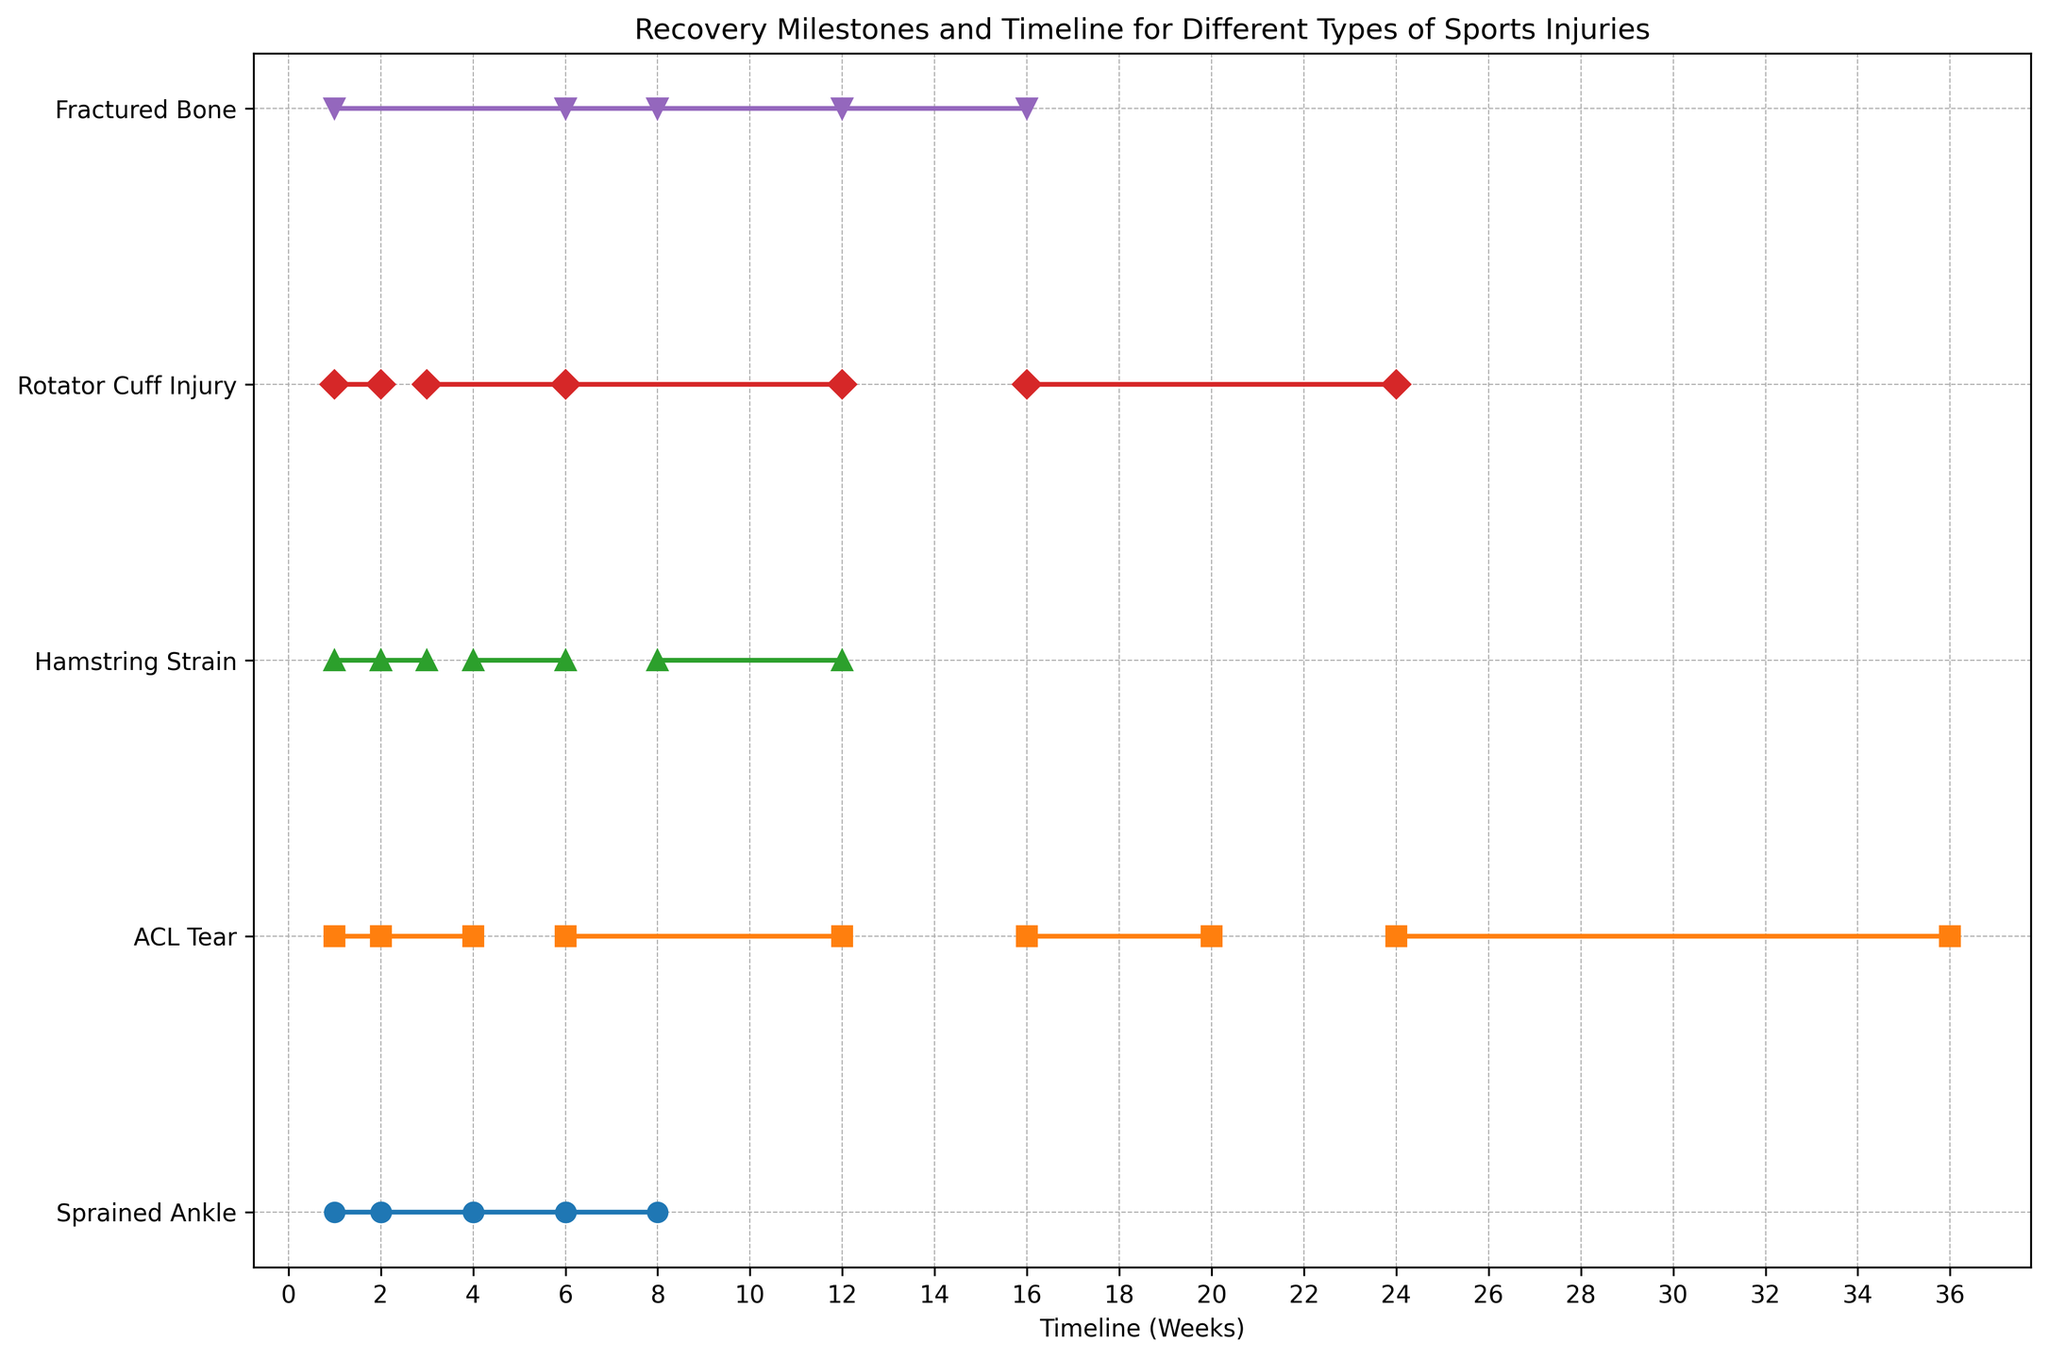What is the shortest initial rest period among all injury types? The shortest initial rest period can be determined by looking for the smallest number in the "Initial Rest" timeline range across all injury types. For Sprained Ankle, ACL Tear, Hamstring Strain, and Rotator Cuff Injury, the range is 1-2 weeks. For Fractured Bone, it is 1-6 weeks. The shortest is 1 week.
Answer: 1 week Which injury type has the longest recovery period before full return to activity? To find the longest recovery period before full return to activity, check the upper limit of the "Full Activity" or "Full Return to Sports" timeline for each injury type. Sprained Ankle is 6-8 weeks, ACL Tear is 24-36 weeks, Hamstring Strain is 8-12 weeks, Rotator Cuff Injury is 16-24 weeks, and Fractured Bone is 12-16 weeks. The longest is ACL Tear with 36 weeks.
Answer: ACL Tear Compare the timeline for initial rest between a Sprained Ankle and an ACL Tear. Are they the same? The timeline for initial rest of both Sprained Ankle and ACL Tear is 1-2 weeks. Since the ranges are identical, the timelines are the same.
Answer: Yes What is the average timeline range for starting physical therapy across all injury types? Find the starting physical therapy timelines for each injury type: Sprained Ankle (2-4), ACL Tear (2-4), Hamstring Strain (none), Rotator Cuff Injury (3-6), and Fractured Bone (6-8). Calculate the midpoint for each: (2+4)/2=3, (2+4)/2=3, (3+6)/2=4.5, (6+8)/2=7. The average is (3 + 3 + 4.5 + 7) / 4 = 4.375 weeks.
Answer: 4.375 weeks Which injury type reaches the full activity milestone within the shortest timeframe? Check the "Full Activity" or "Full Return to Sports" milestones and find the shortest range. Sprained Ankle (6-8 weeks), ACL Tear (24-36 weeks), Hamstring Strain (8-12 weeks), Rotator Cuff Injury (16-24 weeks), Fractured Bone (12-16 weeks). The shortest is 6-8 weeks for Sprained Ankle.
Answer: Sprained Ankle How many injury types have a milestone involving light activity, and what are their timelines for it? Identify injury types with "Light Activity" milestones: Sprained Ankle (4-6 weeks), ACL Tear (16-20 weeks), and Hamstring Strain (4-6 weeks). There are 3 such injury types.
Answer: 3 injury types; 4-6, 16-20, 4-6 weeks What is the median range for the "Initial Rest" period across all injuries? List the ranges for "Initial Rest" for all injury types: 1-2, 1-2, 1-2, 1-2, 1-6. The midpoints are 1.5, 1.5, 1.5, 1.5, and (1+6)/2=3.5. Ordering these: 1.5, 1.5, 1.5, 1.5, 3.5. The median value is the middle one: 1.5.
Answer: 1-2 weeks 